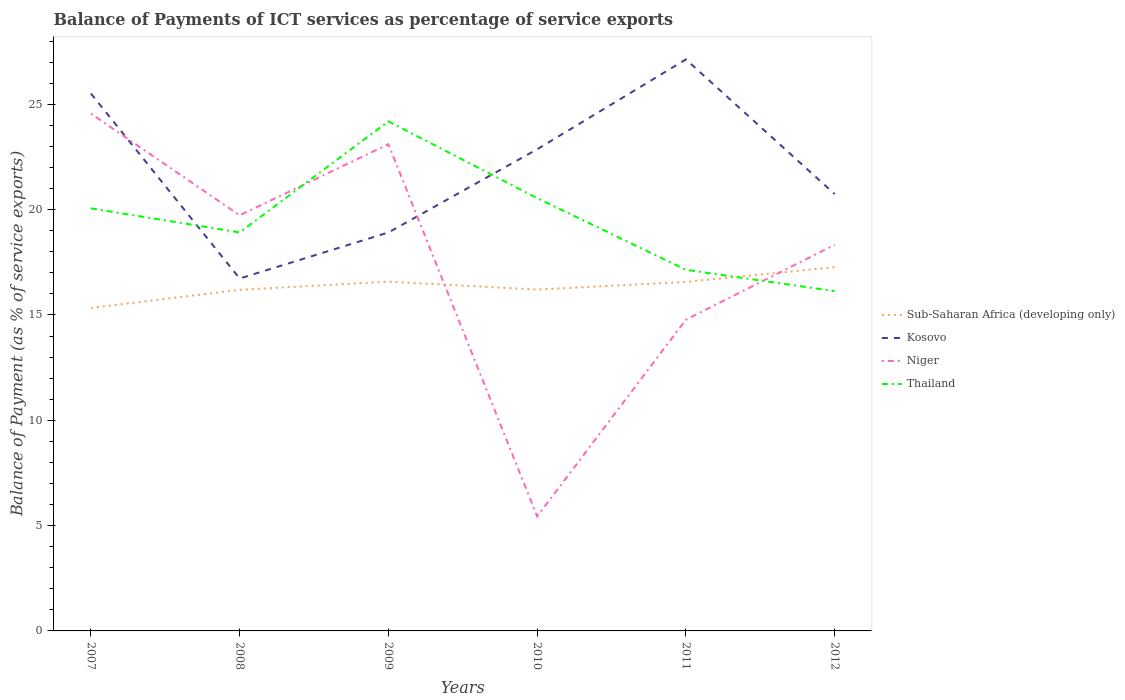Across all years, what is the maximum balance of payments of ICT services in Sub-Saharan Africa (developing only)?
Keep it short and to the point. 15.34. In which year was the balance of payments of ICT services in Thailand maximum?
Your answer should be very brief. 2012. What is the total balance of payments of ICT services in Sub-Saharan Africa (developing only) in the graph?
Provide a succinct answer. -0.38. What is the difference between the highest and the second highest balance of payments of ICT services in Thailand?
Your answer should be compact. 8.06. Are the values on the major ticks of Y-axis written in scientific E-notation?
Your response must be concise. No. Does the graph contain any zero values?
Offer a very short reply. No. Does the graph contain grids?
Your answer should be very brief. No. Where does the legend appear in the graph?
Offer a terse response. Center right. How many legend labels are there?
Keep it short and to the point. 4. What is the title of the graph?
Keep it short and to the point. Balance of Payments of ICT services as percentage of service exports. Does "Thailand" appear as one of the legend labels in the graph?
Provide a short and direct response. Yes. What is the label or title of the X-axis?
Ensure brevity in your answer.  Years. What is the label or title of the Y-axis?
Offer a very short reply. Balance of Payment (as % of service exports). What is the Balance of Payment (as % of service exports) of Sub-Saharan Africa (developing only) in 2007?
Provide a succinct answer. 15.34. What is the Balance of Payment (as % of service exports) of Kosovo in 2007?
Give a very brief answer. 25.51. What is the Balance of Payment (as % of service exports) of Niger in 2007?
Your response must be concise. 24.56. What is the Balance of Payment (as % of service exports) in Thailand in 2007?
Your response must be concise. 20.06. What is the Balance of Payment (as % of service exports) in Sub-Saharan Africa (developing only) in 2008?
Your response must be concise. 16.19. What is the Balance of Payment (as % of service exports) in Kosovo in 2008?
Your response must be concise. 16.73. What is the Balance of Payment (as % of service exports) in Niger in 2008?
Your answer should be compact. 19.73. What is the Balance of Payment (as % of service exports) in Thailand in 2008?
Offer a terse response. 18.92. What is the Balance of Payment (as % of service exports) of Sub-Saharan Africa (developing only) in 2009?
Your response must be concise. 16.58. What is the Balance of Payment (as % of service exports) of Kosovo in 2009?
Your answer should be very brief. 18.92. What is the Balance of Payment (as % of service exports) of Niger in 2009?
Ensure brevity in your answer.  23.11. What is the Balance of Payment (as % of service exports) in Thailand in 2009?
Provide a succinct answer. 24.19. What is the Balance of Payment (as % of service exports) in Sub-Saharan Africa (developing only) in 2010?
Offer a terse response. 16.21. What is the Balance of Payment (as % of service exports) of Kosovo in 2010?
Offer a terse response. 22.87. What is the Balance of Payment (as % of service exports) in Niger in 2010?
Give a very brief answer. 5.44. What is the Balance of Payment (as % of service exports) in Thailand in 2010?
Provide a succinct answer. 20.55. What is the Balance of Payment (as % of service exports) in Sub-Saharan Africa (developing only) in 2011?
Offer a very short reply. 16.57. What is the Balance of Payment (as % of service exports) in Kosovo in 2011?
Your answer should be very brief. 27.13. What is the Balance of Payment (as % of service exports) in Niger in 2011?
Ensure brevity in your answer.  14.78. What is the Balance of Payment (as % of service exports) in Thailand in 2011?
Give a very brief answer. 17.15. What is the Balance of Payment (as % of service exports) in Sub-Saharan Africa (developing only) in 2012?
Make the answer very short. 17.27. What is the Balance of Payment (as % of service exports) of Kosovo in 2012?
Offer a terse response. 20.74. What is the Balance of Payment (as % of service exports) of Niger in 2012?
Provide a succinct answer. 18.33. What is the Balance of Payment (as % of service exports) in Thailand in 2012?
Offer a terse response. 16.13. Across all years, what is the maximum Balance of Payment (as % of service exports) of Sub-Saharan Africa (developing only)?
Make the answer very short. 17.27. Across all years, what is the maximum Balance of Payment (as % of service exports) in Kosovo?
Your response must be concise. 27.13. Across all years, what is the maximum Balance of Payment (as % of service exports) in Niger?
Your response must be concise. 24.56. Across all years, what is the maximum Balance of Payment (as % of service exports) of Thailand?
Provide a succinct answer. 24.19. Across all years, what is the minimum Balance of Payment (as % of service exports) in Sub-Saharan Africa (developing only)?
Keep it short and to the point. 15.34. Across all years, what is the minimum Balance of Payment (as % of service exports) in Kosovo?
Offer a terse response. 16.73. Across all years, what is the minimum Balance of Payment (as % of service exports) in Niger?
Ensure brevity in your answer.  5.44. Across all years, what is the minimum Balance of Payment (as % of service exports) in Thailand?
Provide a short and direct response. 16.13. What is the total Balance of Payment (as % of service exports) of Sub-Saharan Africa (developing only) in the graph?
Provide a short and direct response. 98.16. What is the total Balance of Payment (as % of service exports) in Kosovo in the graph?
Make the answer very short. 131.91. What is the total Balance of Payment (as % of service exports) in Niger in the graph?
Make the answer very short. 105.95. What is the total Balance of Payment (as % of service exports) in Thailand in the graph?
Make the answer very short. 117. What is the difference between the Balance of Payment (as % of service exports) in Sub-Saharan Africa (developing only) in 2007 and that in 2008?
Provide a succinct answer. -0.86. What is the difference between the Balance of Payment (as % of service exports) of Kosovo in 2007 and that in 2008?
Provide a short and direct response. 8.78. What is the difference between the Balance of Payment (as % of service exports) of Niger in 2007 and that in 2008?
Offer a terse response. 4.83. What is the difference between the Balance of Payment (as % of service exports) in Thailand in 2007 and that in 2008?
Offer a terse response. 1.14. What is the difference between the Balance of Payment (as % of service exports) in Sub-Saharan Africa (developing only) in 2007 and that in 2009?
Ensure brevity in your answer.  -1.25. What is the difference between the Balance of Payment (as % of service exports) in Kosovo in 2007 and that in 2009?
Offer a terse response. 6.6. What is the difference between the Balance of Payment (as % of service exports) in Niger in 2007 and that in 2009?
Your answer should be very brief. 1.45. What is the difference between the Balance of Payment (as % of service exports) of Thailand in 2007 and that in 2009?
Give a very brief answer. -4.13. What is the difference between the Balance of Payment (as % of service exports) in Sub-Saharan Africa (developing only) in 2007 and that in 2010?
Provide a succinct answer. -0.87. What is the difference between the Balance of Payment (as % of service exports) in Kosovo in 2007 and that in 2010?
Make the answer very short. 2.65. What is the difference between the Balance of Payment (as % of service exports) in Niger in 2007 and that in 2010?
Keep it short and to the point. 19.12. What is the difference between the Balance of Payment (as % of service exports) in Thailand in 2007 and that in 2010?
Offer a terse response. -0.48. What is the difference between the Balance of Payment (as % of service exports) in Sub-Saharan Africa (developing only) in 2007 and that in 2011?
Ensure brevity in your answer.  -1.23. What is the difference between the Balance of Payment (as % of service exports) of Kosovo in 2007 and that in 2011?
Your answer should be compact. -1.62. What is the difference between the Balance of Payment (as % of service exports) in Niger in 2007 and that in 2011?
Your response must be concise. 9.78. What is the difference between the Balance of Payment (as % of service exports) of Thailand in 2007 and that in 2011?
Ensure brevity in your answer.  2.92. What is the difference between the Balance of Payment (as % of service exports) of Sub-Saharan Africa (developing only) in 2007 and that in 2012?
Ensure brevity in your answer.  -1.93. What is the difference between the Balance of Payment (as % of service exports) in Kosovo in 2007 and that in 2012?
Offer a terse response. 4.77. What is the difference between the Balance of Payment (as % of service exports) in Niger in 2007 and that in 2012?
Provide a short and direct response. 6.23. What is the difference between the Balance of Payment (as % of service exports) of Thailand in 2007 and that in 2012?
Make the answer very short. 3.93. What is the difference between the Balance of Payment (as % of service exports) in Sub-Saharan Africa (developing only) in 2008 and that in 2009?
Make the answer very short. -0.39. What is the difference between the Balance of Payment (as % of service exports) of Kosovo in 2008 and that in 2009?
Ensure brevity in your answer.  -2.19. What is the difference between the Balance of Payment (as % of service exports) in Niger in 2008 and that in 2009?
Your answer should be very brief. -3.37. What is the difference between the Balance of Payment (as % of service exports) of Thailand in 2008 and that in 2009?
Provide a succinct answer. -5.27. What is the difference between the Balance of Payment (as % of service exports) of Sub-Saharan Africa (developing only) in 2008 and that in 2010?
Offer a terse response. -0.01. What is the difference between the Balance of Payment (as % of service exports) of Kosovo in 2008 and that in 2010?
Keep it short and to the point. -6.14. What is the difference between the Balance of Payment (as % of service exports) of Niger in 2008 and that in 2010?
Ensure brevity in your answer.  14.3. What is the difference between the Balance of Payment (as % of service exports) in Thailand in 2008 and that in 2010?
Provide a short and direct response. -1.63. What is the difference between the Balance of Payment (as % of service exports) of Sub-Saharan Africa (developing only) in 2008 and that in 2011?
Make the answer very short. -0.38. What is the difference between the Balance of Payment (as % of service exports) of Kosovo in 2008 and that in 2011?
Your response must be concise. -10.4. What is the difference between the Balance of Payment (as % of service exports) of Niger in 2008 and that in 2011?
Make the answer very short. 4.95. What is the difference between the Balance of Payment (as % of service exports) of Thailand in 2008 and that in 2011?
Your answer should be very brief. 1.77. What is the difference between the Balance of Payment (as % of service exports) in Sub-Saharan Africa (developing only) in 2008 and that in 2012?
Keep it short and to the point. -1.08. What is the difference between the Balance of Payment (as % of service exports) of Kosovo in 2008 and that in 2012?
Offer a very short reply. -4.01. What is the difference between the Balance of Payment (as % of service exports) of Niger in 2008 and that in 2012?
Your response must be concise. 1.4. What is the difference between the Balance of Payment (as % of service exports) in Thailand in 2008 and that in 2012?
Offer a very short reply. 2.79. What is the difference between the Balance of Payment (as % of service exports) of Sub-Saharan Africa (developing only) in 2009 and that in 2010?
Offer a very short reply. 0.38. What is the difference between the Balance of Payment (as % of service exports) of Kosovo in 2009 and that in 2010?
Provide a short and direct response. -3.95. What is the difference between the Balance of Payment (as % of service exports) of Niger in 2009 and that in 2010?
Offer a terse response. 17.67. What is the difference between the Balance of Payment (as % of service exports) in Thailand in 2009 and that in 2010?
Ensure brevity in your answer.  3.65. What is the difference between the Balance of Payment (as % of service exports) of Sub-Saharan Africa (developing only) in 2009 and that in 2011?
Make the answer very short. 0.01. What is the difference between the Balance of Payment (as % of service exports) of Kosovo in 2009 and that in 2011?
Offer a terse response. -8.22. What is the difference between the Balance of Payment (as % of service exports) of Niger in 2009 and that in 2011?
Provide a succinct answer. 8.33. What is the difference between the Balance of Payment (as % of service exports) in Thailand in 2009 and that in 2011?
Offer a terse response. 7.05. What is the difference between the Balance of Payment (as % of service exports) of Sub-Saharan Africa (developing only) in 2009 and that in 2012?
Give a very brief answer. -0.69. What is the difference between the Balance of Payment (as % of service exports) in Kosovo in 2009 and that in 2012?
Your response must be concise. -1.82. What is the difference between the Balance of Payment (as % of service exports) of Niger in 2009 and that in 2012?
Make the answer very short. 4.78. What is the difference between the Balance of Payment (as % of service exports) of Thailand in 2009 and that in 2012?
Your response must be concise. 8.06. What is the difference between the Balance of Payment (as % of service exports) of Sub-Saharan Africa (developing only) in 2010 and that in 2011?
Provide a short and direct response. -0.36. What is the difference between the Balance of Payment (as % of service exports) in Kosovo in 2010 and that in 2011?
Your response must be concise. -4.26. What is the difference between the Balance of Payment (as % of service exports) in Niger in 2010 and that in 2011?
Your response must be concise. -9.34. What is the difference between the Balance of Payment (as % of service exports) of Thailand in 2010 and that in 2011?
Provide a succinct answer. 3.4. What is the difference between the Balance of Payment (as % of service exports) in Sub-Saharan Africa (developing only) in 2010 and that in 2012?
Provide a short and direct response. -1.06. What is the difference between the Balance of Payment (as % of service exports) of Kosovo in 2010 and that in 2012?
Your answer should be compact. 2.13. What is the difference between the Balance of Payment (as % of service exports) in Niger in 2010 and that in 2012?
Your response must be concise. -12.89. What is the difference between the Balance of Payment (as % of service exports) in Thailand in 2010 and that in 2012?
Your response must be concise. 4.42. What is the difference between the Balance of Payment (as % of service exports) of Sub-Saharan Africa (developing only) in 2011 and that in 2012?
Keep it short and to the point. -0.7. What is the difference between the Balance of Payment (as % of service exports) in Kosovo in 2011 and that in 2012?
Provide a succinct answer. 6.39. What is the difference between the Balance of Payment (as % of service exports) in Niger in 2011 and that in 2012?
Make the answer very short. -3.55. What is the difference between the Balance of Payment (as % of service exports) of Thailand in 2011 and that in 2012?
Ensure brevity in your answer.  1.02. What is the difference between the Balance of Payment (as % of service exports) in Sub-Saharan Africa (developing only) in 2007 and the Balance of Payment (as % of service exports) in Kosovo in 2008?
Provide a succinct answer. -1.4. What is the difference between the Balance of Payment (as % of service exports) of Sub-Saharan Africa (developing only) in 2007 and the Balance of Payment (as % of service exports) of Niger in 2008?
Offer a very short reply. -4.4. What is the difference between the Balance of Payment (as % of service exports) of Sub-Saharan Africa (developing only) in 2007 and the Balance of Payment (as % of service exports) of Thailand in 2008?
Provide a succinct answer. -3.58. What is the difference between the Balance of Payment (as % of service exports) of Kosovo in 2007 and the Balance of Payment (as % of service exports) of Niger in 2008?
Offer a terse response. 5.78. What is the difference between the Balance of Payment (as % of service exports) of Kosovo in 2007 and the Balance of Payment (as % of service exports) of Thailand in 2008?
Provide a succinct answer. 6.59. What is the difference between the Balance of Payment (as % of service exports) in Niger in 2007 and the Balance of Payment (as % of service exports) in Thailand in 2008?
Offer a very short reply. 5.64. What is the difference between the Balance of Payment (as % of service exports) of Sub-Saharan Africa (developing only) in 2007 and the Balance of Payment (as % of service exports) of Kosovo in 2009?
Your response must be concise. -3.58. What is the difference between the Balance of Payment (as % of service exports) in Sub-Saharan Africa (developing only) in 2007 and the Balance of Payment (as % of service exports) in Niger in 2009?
Ensure brevity in your answer.  -7.77. What is the difference between the Balance of Payment (as % of service exports) of Sub-Saharan Africa (developing only) in 2007 and the Balance of Payment (as % of service exports) of Thailand in 2009?
Your answer should be very brief. -8.86. What is the difference between the Balance of Payment (as % of service exports) in Kosovo in 2007 and the Balance of Payment (as % of service exports) in Niger in 2009?
Keep it short and to the point. 2.41. What is the difference between the Balance of Payment (as % of service exports) of Kosovo in 2007 and the Balance of Payment (as % of service exports) of Thailand in 2009?
Give a very brief answer. 1.32. What is the difference between the Balance of Payment (as % of service exports) of Niger in 2007 and the Balance of Payment (as % of service exports) of Thailand in 2009?
Give a very brief answer. 0.37. What is the difference between the Balance of Payment (as % of service exports) of Sub-Saharan Africa (developing only) in 2007 and the Balance of Payment (as % of service exports) of Kosovo in 2010?
Your answer should be compact. -7.53. What is the difference between the Balance of Payment (as % of service exports) in Sub-Saharan Africa (developing only) in 2007 and the Balance of Payment (as % of service exports) in Niger in 2010?
Keep it short and to the point. 9.9. What is the difference between the Balance of Payment (as % of service exports) in Sub-Saharan Africa (developing only) in 2007 and the Balance of Payment (as % of service exports) in Thailand in 2010?
Your response must be concise. -5.21. What is the difference between the Balance of Payment (as % of service exports) in Kosovo in 2007 and the Balance of Payment (as % of service exports) in Niger in 2010?
Provide a succinct answer. 20.08. What is the difference between the Balance of Payment (as % of service exports) of Kosovo in 2007 and the Balance of Payment (as % of service exports) of Thailand in 2010?
Give a very brief answer. 4.97. What is the difference between the Balance of Payment (as % of service exports) in Niger in 2007 and the Balance of Payment (as % of service exports) in Thailand in 2010?
Your answer should be compact. 4.01. What is the difference between the Balance of Payment (as % of service exports) in Sub-Saharan Africa (developing only) in 2007 and the Balance of Payment (as % of service exports) in Kosovo in 2011?
Provide a short and direct response. -11.8. What is the difference between the Balance of Payment (as % of service exports) of Sub-Saharan Africa (developing only) in 2007 and the Balance of Payment (as % of service exports) of Niger in 2011?
Your response must be concise. 0.56. What is the difference between the Balance of Payment (as % of service exports) of Sub-Saharan Africa (developing only) in 2007 and the Balance of Payment (as % of service exports) of Thailand in 2011?
Ensure brevity in your answer.  -1.81. What is the difference between the Balance of Payment (as % of service exports) of Kosovo in 2007 and the Balance of Payment (as % of service exports) of Niger in 2011?
Ensure brevity in your answer.  10.74. What is the difference between the Balance of Payment (as % of service exports) in Kosovo in 2007 and the Balance of Payment (as % of service exports) in Thailand in 2011?
Provide a short and direct response. 8.37. What is the difference between the Balance of Payment (as % of service exports) of Niger in 2007 and the Balance of Payment (as % of service exports) of Thailand in 2011?
Keep it short and to the point. 7.41. What is the difference between the Balance of Payment (as % of service exports) of Sub-Saharan Africa (developing only) in 2007 and the Balance of Payment (as % of service exports) of Kosovo in 2012?
Offer a very short reply. -5.41. What is the difference between the Balance of Payment (as % of service exports) in Sub-Saharan Africa (developing only) in 2007 and the Balance of Payment (as % of service exports) in Niger in 2012?
Keep it short and to the point. -3. What is the difference between the Balance of Payment (as % of service exports) in Sub-Saharan Africa (developing only) in 2007 and the Balance of Payment (as % of service exports) in Thailand in 2012?
Your response must be concise. -0.8. What is the difference between the Balance of Payment (as % of service exports) in Kosovo in 2007 and the Balance of Payment (as % of service exports) in Niger in 2012?
Provide a succinct answer. 7.18. What is the difference between the Balance of Payment (as % of service exports) of Kosovo in 2007 and the Balance of Payment (as % of service exports) of Thailand in 2012?
Offer a very short reply. 9.38. What is the difference between the Balance of Payment (as % of service exports) in Niger in 2007 and the Balance of Payment (as % of service exports) in Thailand in 2012?
Ensure brevity in your answer.  8.43. What is the difference between the Balance of Payment (as % of service exports) in Sub-Saharan Africa (developing only) in 2008 and the Balance of Payment (as % of service exports) in Kosovo in 2009?
Offer a very short reply. -2.72. What is the difference between the Balance of Payment (as % of service exports) of Sub-Saharan Africa (developing only) in 2008 and the Balance of Payment (as % of service exports) of Niger in 2009?
Offer a terse response. -6.91. What is the difference between the Balance of Payment (as % of service exports) of Sub-Saharan Africa (developing only) in 2008 and the Balance of Payment (as % of service exports) of Thailand in 2009?
Ensure brevity in your answer.  -8. What is the difference between the Balance of Payment (as % of service exports) in Kosovo in 2008 and the Balance of Payment (as % of service exports) in Niger in 2009?
Provide a succinct answer. -6.37. What is the difference between the Balance of Payment (as % of service exports) of Kosovo in 2008 and the Balance of Payment (as % of service exports) of Thailand in 2009?
Your answer should be compact. -7.46. What is the difference between the Balance of Payment (as % of service exports) in Niger in 2008 and the Balance of Payment (as % of service exports) in Thailand in 2009?
Your response must be concise. -4.46. What is the difference between the Balance of Payment (as % of service exports) of Sub-Saharan Africa (developing only) in 2008 and the Balance of Payment (as % of service exports) of Kosovo in 2010?
Provide a short and direct response. -6.68. What is the difference between the Balance of Payment (as % of service exports) in Sub-Saharan Africa (developing only) in 2008 and the Balance of Payment (as % of service exports) in Niger in 2010?
Your answer should be very brief. 10.76. What is the difference between the Balance of Payment (as % of service exports) of Sub-Saharan Africa (developing only) in 2008 and the Balance of Payment (as % of service exports) of Thailand in 2010?
Make the answer very short. -4.35. What is the difference between the Balance of Payment (as % of service exports) of Kosovo in 2008 and the Balance of Payment (as % of service exports) of Niger in 2010?
Your response must be concise. 11.29. What is the difference between the Balance of Payment (as % of service exports) in Kosovo in 2008 and the Balance of Payment (as % of service exports) in Thailand in 2010?
Offer a very short reply. -3.82. What is the difference between the Balance of Payment (as % of service exports) in Niger in 2008 and the Balance of Payment (as % of service exports) in Thailand in 2010?
Your answer should be compact. -0.81. What is the difference between the Balance of Payment (as % of service exports) in Sub-Saharan Africa (developing only) in 2008 and the Balance of Payment (as % of service exports) in Kosovo in 2011?
Your answer should be very brief. -10.94. What is the difference between the Balance of Payment (as % of service exports) in Sub-Saharan Africa (developing only) in 2008 and the Balance of Payment (as % of service exports) in Niger in 2011?
Provide a succinct answer. 1.42. What is the difference between the Balance of Payment (as % of service exports) of Sub-Saharan Africa (developing only) in 2008 and the Balance of Payment (as % of service exports) of Thailand in 2011?
Keep it short and to the point. -0.95. What is the difference between the Balance of Payment (as % of service exports) in Kosovo in 2008 and the Balance of Payment (as % of service exports) in Niger in 2011?
Give a very brief answer. 1.95. What is the difference between the Balance of Payment (as % of service exports) of Kosovo in 2008 and the Balance of Payment (as % of service exports) of Thailand in 2011?
Provide a short and direct response. -0.41. What is the difference between the Balance of Payment (as % of service exports) of Niger in 2008 and the Balance of Payment (as % of service exports) of Thailand in 2011?
Provide a short and direct response. 2.59. What is the difference between the Balance of Payment (as % of service exports) of Sub-Saharan Africa (developing only) in 2008 and the Balance of Payment (as % of service exports) of Kosovo in 2012?
Offer a terse response. -4.55. What is the difference between the Balance of Payment (as % of service exports) in Sub-Saharan Africa (developing only) in 2008 and the Balance of Payment (as % of service exports) in Niger in 2012?
Provide a succinct answer. -2.14. What is the difference between the Balance of Payment (as % of service exports) of Sub-Saharan Africa (developing only) in 2008 and the Balance of Payment (as % of service exports) of Thailand in 2012?
Your answer should be compact. 0.06. What is the difference between the Balance of Payment (as % of service exports) in Kosovo in 2008 and the Balance of Payment (as % of service exports) in Niger in 2012?
Provide a short and direct response. -1.6. What is the difference between the Balance of Payment (as % of service exports) of Kosovo in 2008 and the Balance of Payment (as % of service exports) of Thailand in 2012?
Provide a succinct answer. 0.6. What is the difference between the Balance of Payment (as % of service exports) of Niger in 2008 and the Balance of Payment (as % of service exports) of Thailand in 2012?
Your response must be concise. 3.6. What is the difference between the Balance of Payment (as % of service exports) of Sub-Saharan Africa (developing only) in 2009 and the Balance of Payment (as % of service exports) of Kosovo in 2010?
Offer a terse response. -6.29. What is the difference between the Balance of Payment (as % of service exports) of Sub-Saharan Africa (developing only) in 2009 and the Balance of Payment (as % of service exports) of Niger in 2010?
Your answer should be compact. 11.14. What is the difference between the Balance of Payment (as % of service exports) of Sub-Saharan Africa (developing only) in 2009 and the Balance of Payment (as % of service exports) of Thailand in 2010?
Your response must be concise. -3.97. What is the difference between the Balance of Payment (as % of service exports) of Kosovo in 2009 and the Balance of Payment (as % of service exports) of Niger in 2010?
Give a very brief answer. 13.48. What is the difference between the Balance of Payment (as % of service exports) in Kosovo in 2009 and the Balance of Payment (as % of service exports) in Thailand in 2010?
Keep it short and to the point. -1.63. What is the difference between the Balance of Payment (as % of service exports) of Niger in 2009 and the Balance of Payment (as % of service exports) of Thailand in 2010?
Your answer should be compact. 2.56. What is the difference between the Balance of Payment (as % of service exports) in Sub-Saharan Africa (developing only) in 2009 and the Balance of Payment (as % of service exports) in Kosovo in 2011?
Give a very brief answer. -10.55. What is the difference between the Balance of Payment (as % of service exports) in Sub-Saharan Africa (developing only) in 2009 and the Balance of Payment (as % of service exports) in Niger in 2011?
Give a very brief answer. 1.8. What is the difference between the Balance of Payment (as % of service exports) in Sub-Saharan Africa (developing only) in 2009 and the Balance of Payment (as % of service exports) in Thailand in 2011?
Make the answer very short. -0.56. What is the difference between the Balance of Payment (as % of service exports) in Kosovo in 2009 and the Balance of Payment (as % of service exports) in Niger in 2011?
Offer a terse response. 4.14. What is the difference between the Balance of Payment (as % of service exports) in Kosovo in 2009 and the Balance of Payment (as % of service exports) in Thailand in 2011?
Offer a terse response. 1.77. What is the difference between the Balance of Payment (as % of service exports) of Niger in 2009 and the Balance of Payment (as % of service exports) of Thailand in 2011?
Your answer should be compact. 5.96. What is the difference between the Balance of Payment (as % of service exports) of Sub-Saharan Africa (developing only) in 2009 and the Balance of Payment (as % of service exports) of Kosovo in 2012?
Offer a terse response. -4.16. What is the difference between the Balance of Payment (as % of service exports) of Sub-Saharan Africa (developing only) in 2009 and the Balance of Payment (as % of service exports) of Niger in 2012?
Make the answer very short. -1.75. What is the difference between the Balance of Payment (as % of service exports) in Sub-Saharan Africa (developing only) in 2009 and the Balance of Payment (as % of service exports) in Thailand in 2012?
Offer a terse response. 0.45. What is the difference between the Balance of Payment (as % of service exports) in Kosovo in 2009 and the Balance of Payment (as % of service exports) in Niger in 2012?
Your answer should be compact. 0.59. What is the difference between the Balance of Payment (as % of service exports) of Kosovo in 2009 and the Balance of Payment (as % of service exports) of Thailand in 2012?
Offer a very short reply. 2.79. What is the difference between the Balance of Payment (as % of service exports) of Niger in 2009 and the Balance of Payment (as % of service exports) of Thailand in 2012?
Give a very brief answer. 6.97. What is the difference between the Balance of Payment (as % of service exports) of Sub-Saharan Africa (developing only) in 2010 and the Balance of Payment (as % of service exports) of Kosovo in 2011?
Give a very brief answer. -10.93. What is the difference between the Balance of Payment (as % of service exports) of Sub-Saharan Africa (developing only) in 2010 and the Balance of Payment (as % of service exports) of Niger in 2011?
Offer a very short reply. 1.43. What is the difference between the Balance of Payment (as % of service exports) of Sub-Saharan Africa (developing only) in 2010 and the Balance of Payment (as % of service exports) of Thailand in 2011?
Your answer should be very brief. -0.94. What is the difference between the Balance of Payment (as % of service exports) in Kosovo in 2010 and the Balance of Payment (as % of service exports) in Niger in 2011?
Offer a terse response. 8.09. What is the difference between the Balance of Payment (as % of service exports) of Kosovo in 2010 and the Balance of Payment (as % of service exports) of Thailand in 2011?
Give a very brief answer. 5.72. What is the difference between the Balance of Payment (as % of service exports) in Niger in 2010 and the Balance of Payment (as % of service exports) in Thailand in 2011?
Keep it short and to the point. -11.71. What is the difference between the Balance of Payment (as % of service exports) of Sub-Saharan Africa (developing only) in 2010 and the Balance of Payment (as % of service exports) of Kosovo in 2012?
Provide a succinct answer. -4.53. What is the difference between the Balance of Payment (as % of service exports) in Sub-Saharan Africa (developing only) in 2010 and the Balance of Payment (as % of service exports) in Niger in 2012?
Make the answer very short. -2.12. What is the difference between the Balance of Payment (as % of service exports) of Sub-Saharan Africa (developing only) in 2010 and the Balance of Payment (as % of service exports) of Thailand in 2012?
Provide a succinct answer. 0.08. What is the difference between the Balance of Payment (as % of service exports) in Kosovo in 2010 and the Balance of Payment (as % of service exports) in Niger in 2012?
Offer a very short reply. 4.54. What is the difference between the Balance of Payment (as % of service exports) of Kosovo in 2010 and the Balance of Payment (as % of service exports) of Thailand in 2012?
Your response must be concise. 6.74. What is the difference between the Balance of Payment (as % of service exports) in Niger in 2010 and the Balance of Payment (as % of service exports) in Thailand in 2012?
Your answer should be very brief. -10.69. What is the difference between the Balance of Payment (as % of service exports) of Sub-Saharan Africa (developing only) in 2011 and the Balance of Payment (as % of service exports) of Kosovo in 2012?
Offer a very short reply. -4.17. What is the difference between the Balance of Payment (as % of service exports) of Sub-Saharan Africa (developing only) in 2011 and the Balance of Payment (as % of service exports) of Niger in 2012?
Your answer should be compact. -1.76. What is the difference between the Balance of Payment (as % of service exports) in Sub-Saharan Africa (developing only) in 2011 and the Balance of Payment (as % of service exports) in Thailand in 2012?
Provide a succinct answer. 0.44. What is the difference between the Balance of Payment (as % of service exports) of Kosovo in 2011 and the Balance of Payment (as % of service exports) of Niger in 2012?
Your answer should be very brief. 8.8. What is the difference between the Balance of Payment (as % of service exports) in Kosovo in 2011 and the Balance of Payment (as % of service exports) in Thailand in 2012?
Offer a very short reply. 11. What is the difference between the Balance of Payment (as % of service exports) in Niger in 2011 and the Balance of Payment (as % of service exports) in Thailand in 2012?
Your answer should be compact. -1.35. What is the average Balance of Payment (as % of service exports) of Sub-Saharan Africa (developing only) per year?
Offer a very short reply. 16.36. What is the average Balance of Payment (as % of service exports) in Kosovo per year?
Your answer should be compact. 21.98. What is the average Balance of Payment (as % of service exports) of Niger per year?
Your answer should be compact. 17.66. What is the average Balance of Payment (as % of service exports) of Thailand per year?
Provide a short and direct response. 19.5. In the year 2007, what is the difference between the Balance of Payment (as % of service exports) in Sub-Saharan Africa (developing only) and Balance of Payment (as % of service exports) in Kosovo?
Offer a very short reply. -10.18. In the year 2007, what is the difference between the Balance of Payment (as % of service exports) in Sub-Saharan Africa (developing only) and Balance of Payment (as % of service exports) in Niger?
Provide a succinct answer. -9.22. In the year 2007, what is the difference between the Balance of Payment (as % of service exports) in Sub-Saharan Africa (developing only) and Balance of Payment (as % of service exports) in Thailand?
Offer a very short reply. -4.73. In the year 2007, what is the difference between the Balance of Payment (as % of service exports) of Kosovo and Balance of Payment (as % of service exports) of Niger?
Keep it short and to the point. 0.95. In the year 2007, what is the difference between the Balance of Payment (as % of service exports) of Kosovo and Balance of Payment (as % of service exports) of Thailand?
Your answer should be compact. 5.45. In the year 2007, what is the difference between the Balance of Payment (as % of service exports) of Niger and Balance of Payment (as % of service exports) of Thailand?
Your response must be concise. 4.5. In the year 2008, what is the difference between the Balance of Payment (as % of service exports) in Sub-Saharan Africa (developing only) and Balance of Payment (as % of service exports) in Kosovo?
Offer a terse response. -0.54. In the year 2008, what is the difference between the Balance of Payment (as % of service exports) in Sub-Saharan Africa (developing only) and Balance of Payment (as % of service exports) in Niger?
Provide a short and direct response. -3.54. In the year 2008, what is the difference between the Balance of Payment (as % of service exports) of Sub-Saharan Africa (developing only) and Balance of Payment (as % of service exports) of Thailand?
Your answer should be very brief. -2.73. In the year 2008, what is the difference between the Balance of Payment (as % of service exports) in Kosovo and Balance of Payment (as % of service exports) in Niger?
Ensure brevity in your answer.  -3. In the year 2008, what is the difference between the Balance of Payment (as % of service exports) in Kosovo and Balance of Payment (as % of service exports) in Thailand?
Your response must be concise. -2.19. In the year 2008, what is the difference between the Balance of Payment (as % of service exports) of Niger and Balance of Payment (as % of service exports) of Thailand?
Keep it short and to the point. 0.81. In the year 2009, what is the difference between the Balance of Payment (as % of service exports) of Sub-Saharan Africa (developing only) and Balance of Payment (as % of service exports) of Kosovo?
Your answer should be very brief. -2.33. In the year 2009, what is the difference between the Balance of Payment (as % of service exports) of Sub-Saharan Africa (developing only) and Balance of Payment (as % of service exports) of Niger?
Offer a terse response. -6.52. In the year 2009, what is the difference between the Balance of Payment (as % of service exports) in Sub-Saharan Africa (developing only) and Balance of Payment (as % of service exports) in Thailand?
Your response must be concise. -7.61. In the year 2009, what is the difference between the Balance of Payment (as % of service exports) of Kosovo and Balance of Payment (as % of service exports) of Niger?
Offer a very short reply. -4.19. In the year 2009, what is the difference between the Balance of Payment (as % of service exports) in Kosovo and Balance of Payment (as % of service exports) in Thailand?
Provide a succinct answer. -5.28. In the year 2009, what is the difference between the Balance of Payment (as % of service exports) of Niger and Balance of Payment (as % of service exports) of Thailand?
Make the answer very short. -1.09. In the year 2010, what is the difference between the Balance of Payment (as % of service exports) in Sub-Saharan Africa (developing only) and Balance of Payment (as % of service exports) in Kosovo?
Offer a very short reply. -6.66. In the year 2010, what is the difference between the Balance of Payment (as % of service exports) in Sub-Saharan Africa (developing only) and Balance of Payment (as % of service exports) in Niger?
Ensure brevity in your answer.  10.77. In the year 2010, what is the difference between the Balance of Payment (as % of service exports) of Sub-Saharan Africa (developing only) and Balance of Payment (as % of service exports) of Thailand?
Your answer should be very brief. -4.34. In the year 2010, what is the difference between the Balance of Payment (as % of service exports) in Kosovo and Balance of Payment (as % of service exports) in Niger?
Make the answer very short. 17.43. In the year 2010, what is the difference between the Balance of Payment (as % of service exports) in Kosovo and Balance of Payment (as % of service exports) in Thailand?
Keep it short and to the point. 2.32. In the year 2010, what is the difference between the Balance of Payment (as % of service exports) in Niger and Balance of Payment (as % of service exports) in Thailand?
Your answer should be compact. -15.11. In the year 2011, what is the difference between the Balance of Payment (as % of service exports) in Sub-Saharan Africa (developing only) and Balance of Payment (as % of service exports) in Kosovo?
Make the answer very short. -10.56. In the year 2011, what is the difference between the Balance of Payment (as % of service exports) in Sub-Saharan Africa (developing only) and Balance of Payment (as % of service exports) in Niger?
Offer a terse response. 1.79. In the year 2011, what is the difference between the Balance of Payment (as % of service exports) in Sub-Saharan Africa (developing only) and Balance of Payment (as % of service exports) in Thailand?
Your answer should be compact. -0.58. In the year 2011, what is the difference between the Balance of Payment (as % of service exports) of Kosovo and Balance of Payment (as % of service exports) of Niger?
Your answer should be compact. 12.35. In the year 2011, what is the difference between the Balance of Payment (as % of service exports) of Kosovo and Balance of Payment (as % of service exports) of Thailand?
Make the answer very short. 9.99. In the year 2011, what is the difference between the Balance of Payment (as % of service exports) in Niger and Balance of Payment (as % of service exports) in Thailand?
Ensure brevity in your answer.  -2.37. In the year 2012, what is the difference between the Balance of Payment (as % of service exports) in Sub-Saharan Africa (developing only) and Balance of Payment (as % of service exports) in Kosovo?
Provide a succinct answer. -3.47. In the year 2012, what is the difference between the Balance of Payment (as % of service exports) in Sub-Saharan Africa (developing only) and Balance of Payment (as % of service exports) in Niger?
Your response must be concise. -1.06. In the year 2012, what is the difference between the Balance of Payment (as % of service exports) in Sub-Saharan Africa (developing only) and Balance of Payment (as % of service exports) in Thailand?
Provide a short and direct response. 1.14. In the year 2012, what is the difference between the Balance of Payment (as % of service exports) in Kosovo and Balance of Payment (as % of service exports) in Niger?
Offer a very short reply. 2.41. In the year 2012, what is the difference between the Balance of Payment (as % of service exports) of Kosovo and Balance of Payment (as % of service exports) of Thailand?
Your answer should be very brief. 4.61. In the year 2012, what is the difference between the Balance of Payment (as % of service exports) of Niger and Balance of Payment (as % of service exports) of Thailand?
Make the answer very short. 2.2. What is the ratio of the Balance of Payment (as % of service exports) of Sub-Saharan Africa (developing only) in 2007 to that in 2008?
Make the answer very short. 0.95. What is the ratio of the Balance of Payment (as % of service exports) of Kosovo in 2007 to that in 2008?
Your response must be concise. 1.52. What is the ratio of the Balance of Payment (as % of service exports) in Niger in 2007 to that in 2008?
Provide a succinct answer. 1.24. What is the ratio of the Balance of Payment (as % of service exports) of Thailand in 2007 to that in 2008?
Your answer should be compact. 1.06. What is the ratio of the Balance of Payment (as % of service exports) in Sub-Saharan Africa (developing only) in 2007 to that in 2009?
Your answer should be very brief. 0.92. What is the ratio of the Balance of Payment (as % of service exports) in Kosovo in 2007 to that in 2009?
Offer a very short reply. 1.35. What is the ratio of the Balance of Payment (as % of service exports) in Niger in 2007 to that in 2009?
Your answer should be compact. 1.06. What is the ratio of the Balance of Payment (as % of service exports) in Thailand in 2007 to that in 2009?
Your answer should be compact. 0.83. What is the ratio of the Balance of Payment (as % of service exports) in Sub-Saharan Africa (developing only) in 2007 to that in 2010?
Ensure brevity in your answer.  0.95. What is the ratio of the Balance of Payment (as % of service exports) in Kosovo in 2007 to that in 2010?
Keep it short and to the point. 1.12. What is the ratio of the Balance of Payment (as % of service exports) in Niger in 2007 to that in 2010?
Your response must be concise. 4.52. What is the ratio of the Balance of Payment (as % of service exports) of Thailand in 2007 to that in 2010?
Provide a short and direct response. 0.98. What is the ratio of the Balance of Payment (as % of service exports) in Sub-Saharan Africa (developing only) in 2007 to that in 2011?
Provide a succinct answer. 0.93. What is the ratio of the Balance of Payment (as % of service exports) of Kosovo in 2007 to that in 2011?
Ensure brevity in your answer.  0.94. What is the ratio of the Balance of Payment (as % of service exports) in Niger in 2007 to that in 2011?
Offer a terse response. 1.66. What is the ratio of the Balance of Payment (as % of service exports) of Thailand in 2007 to that in 2011?
Your answer should be compact. 1.17. What is the ratio of the Balance of Payment (as % of service exports) of Sub-Saharan Africa (developing only) in 2007 to that in 2012?
Give a very brief answer. 0.89. What is the ratio of the Balance of Payment (as % of service exports) of Kosovo in 2007 to that in 2012?
Your response must be concise. 1.23. What is the ratio of the Balance of Payment (as % of service exports) of Niger in 2007 to that in 2012?
Your answer should be very brief. 1.34. What is the ratio of the Balance of Payment (as % of service exports) of Thailand in 2007 to that in 2012?
Your response must be concise. 1.24. What is the ratio of the Balance of Payment (as % of service exports) in Sub-Saharan Africa (developing only) in 2008 to that in 2009?
Offer a terse response. 0.98. What is the ratio of the Balance of Payment (as % of service exports) of Kosovo in 2008 to that in 2009?
Offer a very short reply. 0.88. What is the ratio of the Balance of Payment (as % of service exports) in Niger in 2008 to that in 2009?
Your response must be concise. 0.85. What is the ratio of the Balance of Payment (as % of service exports) in Thailand in 2008 to that in 2009?
Provide a succinct answer. 0.78. What is the ratio of the Balance of Payment (as % of service exports) in Kosovo in 2008 to that in 2010?
Provide a succinct answer. 0.73. What is the ratio of the Balance of Payment (as % of service exports) of Niger in 2008 to that in 2010?
Provide a succinct answer. 3.63. What is the ratio of the Balance of Payment (as % of service exports) in Thailand in 2008 to that in 2010?
Ensure brevity in your answer.  0.92. What is the ratio of the Balance of Payment (as % of service exports) in Sub-Saharan Africa (developing only) in 2008 to that in 2011?
Offer a very short reply. 0.98. What is the ratio of the Balance of Payment (as % of service exports) in Kosovo in 2008 to that in 2011?
Give a very brief answer. 0.62. What is the ratio of the Balance of Payment (as % of service exports) in Niger in 2008 to that in 2011?
Your answer should be compact. 1.34. What is the ratio of the Balance of Payment (as % of service exports) in Thailand in 2008 to that in 2011?
Your answer should be very brief. 1.1. What is the ratio of the Balance of Payment (as % of service exports) of Sub-Saharan Africa (developing only) in 2008 to that in 2012?
Offer a terse response. 0.94. What is the ratio of the Balance of Payment (as % of service exports) in Kosovo in 2008 to that in 2012?
Ensure brevity in your answer.  0.81. What is the ratio of the Balance of Payment (as % of service exports) in Niger in 2008 to that in 2012?
Offer a terse response. 1.08. What is the ratio of the Balance of Payment (as % of service exports) in Thailand in 2008 to that in 2012?
Your answer should be very brief. 1.17. What is the ratio of the Balance of Payment (as % of service exports) of Sub-Saharan Africa (developing only) in 2009 to that in 2010?
Your response must be concise. 1.02. What is the ratio of the Balance of Payment (as % of service exports) of Kosovo in 2009 to that in 2010?
Provide a short and direct response. 0.83. What is the ratio of the Balance of Payment (as % of service exports) of Niger in 2009 to that in 2010?
Offer a very short reply. 4.25. What is the ratio of the Balance of Payment (as % of service exports) of Thailand in 2009 to that in 2010?
Your response must be concise. 1.18. What is the ratio of the Balance of Payment (as % of service exports) of Sub-Saharan Africa (developing only) in 2009 to that in 2011?
Ensure brevity in your answer.  1. What is the ratio of the Balance of Payment (as % of service exports) in Kosovo in 2009 to that in 2011?
Ensure brevity in your answer.  0.7. What is the ratio of the Balance of Payment (as % of service exports) of Niger in 2009 to that in 2011?
Give a very brief answer. 1.56. What is the ratio of the Balance of Payment (as % of service exports) in Thailand in 2009 to that in 2011?
Give a very brief answer. 1.41. What is the ratio of the Balance of Payment (as % of service exports) of Sub-Saharan Africa (developing only) in 2009 to that in 2012?
Offer a terse response. 0.96. What is the ratio of the Balance of Payment (as % of service exports) in Kosovo in 2009 to that in 2012?
Ensure brevity in your answer.  0.91. What is the ratio of the Balance of Payment (as % of service exports) of Niger in 2009 to that in 2012?
Give a very brief answer. 1.26. What is the ratio of the Balance of Payment (as % of service exports) in Thailand in 2009 to that in 2012?
Keep it short and to the point. 1.5. What is the ratio of the Balance of Payment (as % of service exports) in Sub-Saharan Africa (developing only) in 2010 to that in 2011?
Keep it short and to the point. 0.98. What is the ratio of the Balance of Payment (as % of service exports) in Kosovo in 2010 to that in 2011?
Your answer should be very brief. 0.84. What is the ratio of the Balance of Payment (as % of service exports) of Niger in 2010 to that in 2011?
Your answer should be compact. 0.37. What is the ratio of the Balance of Payment (as % of service exports) in Thailand in 2010 to that in 2011?
Your answer should be compact. 1.2. What is the ratio of the Balance of Payment (as % of service exports) of Sub-Saharan Africa (developing only) in 2010 to that in 2012?
Give a very brief answer. 0.94. What is the ratio of the Balance of Payment (as % of service exports) in Kosovo in 2010 to that in 2012?
Make the answer very short. 1.1. What is the ratio of the Balance of Payment (as % of service exports) of Niger in 2010 to that in 2012?
Offer a very short reply. 0.3. What is the ratio of the Balance of Payment (as % of service exports) of Thailand in 2010 to that in 2012?
Provide a succinct answer. 1.27. What is the ratio of the Balance of Payment (as % of service exports) in Sub-Saharan Africa (developing only) in 2011 to that in 2012?
Your response must be concise. 0.96. What is the ratio of the Balance of Payment (as % of service exports) in Kosovo in 2011 to that in 2012?
Offer a very short reply. 1.31. What is the ratio of the Balance of Payment (as % of service exports) of Niger in 2011 to that in 2012?
Keep it short and to the point. 0.81. What is the ratio of the Balance of Payment (as % of service exports) in Thailand in 2011 to that in 2012?
Your response must be concise. 1.06. What is the difference between the highest and the second highest Balance of Payment (as % of service exports) of Sub-Saharan Africa (developing only)?
Give a very brief answer. 0.69. What is the difference between the highest and the second highest Balance of Payment (as % of service exports) of Kosovo?
Keep it short and to the point. 1.62. What is the difference between the highest and the second highest Balance of Payment (as % of service exports) in Niger?
Your answer should be very brief. 1.45. What is the difference between the highest and the second highest Balance of Payment (as % of service exports) in Thailand?
Your response must be concise. 3.65. What is the difference between the highest and the lowest Balance of Payment (as % of service exports) of Sub-Saharan Africa (developing only)?
Your response must be concise. 1.93. What is the difference between the highest and the lowest Balance of Payment (as % of service exports) in Kosovo?
Ensure brevity in your answer.  10.4. What is the difference between the highest and the lowest Balance of Payment (as % of service exports) of Niger?
Your answer should be very brief. 19.12. What is the difference between the highest and the lowest Balance of Payment (as % of service exports) of Thailand?
Provide a succinct answer. 8.06. 